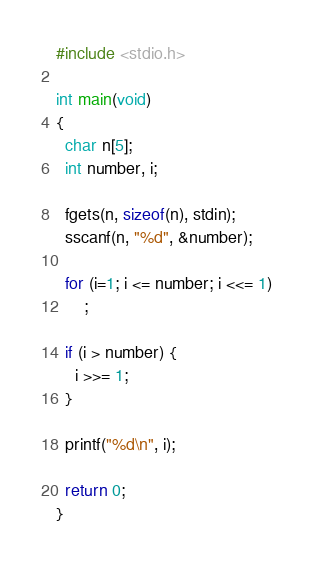<code> <loc_0><loc_0><loc_500><loc_500><_C_>#include <stdio.h>

int main(void)
{
  char n[5];
  int number, i;

  fgets(n, sizeof(n), stdin);
  sscanf(n, "%d", &number);

  for (i=1; i <= number; i <<= 1)
      ;

  if (i > number) {
    i >>= 1;
  }

  printf("%d\n", i);
  
  return 0;
}
</code> 